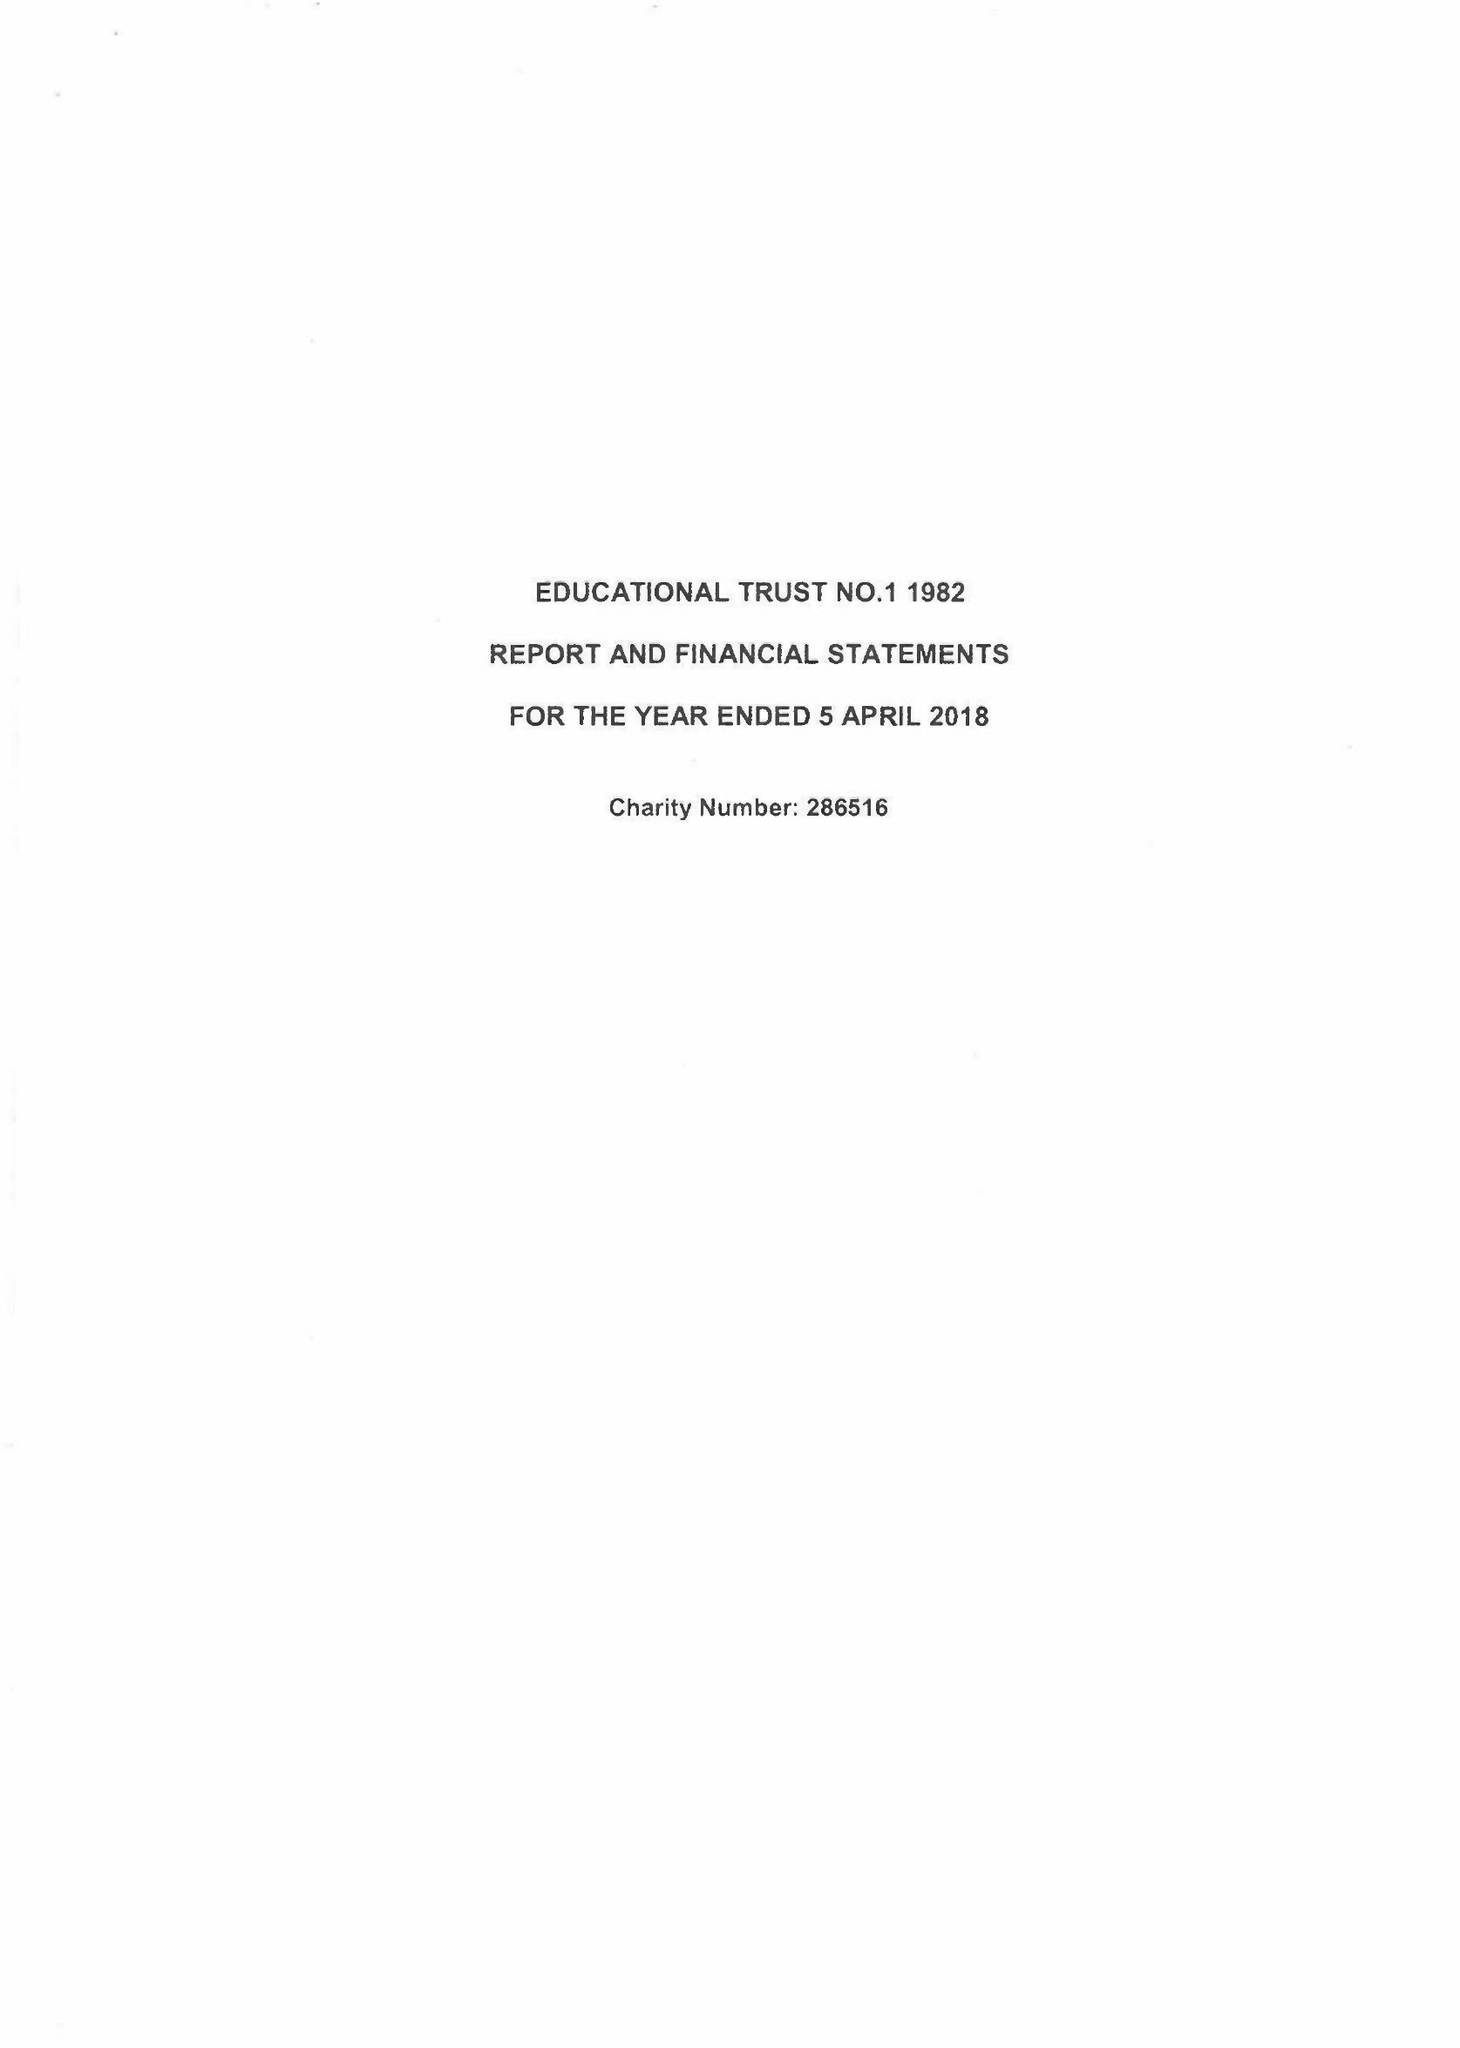What is the value for the charity_number?
Answer the question using a single word or phrase. 286516 